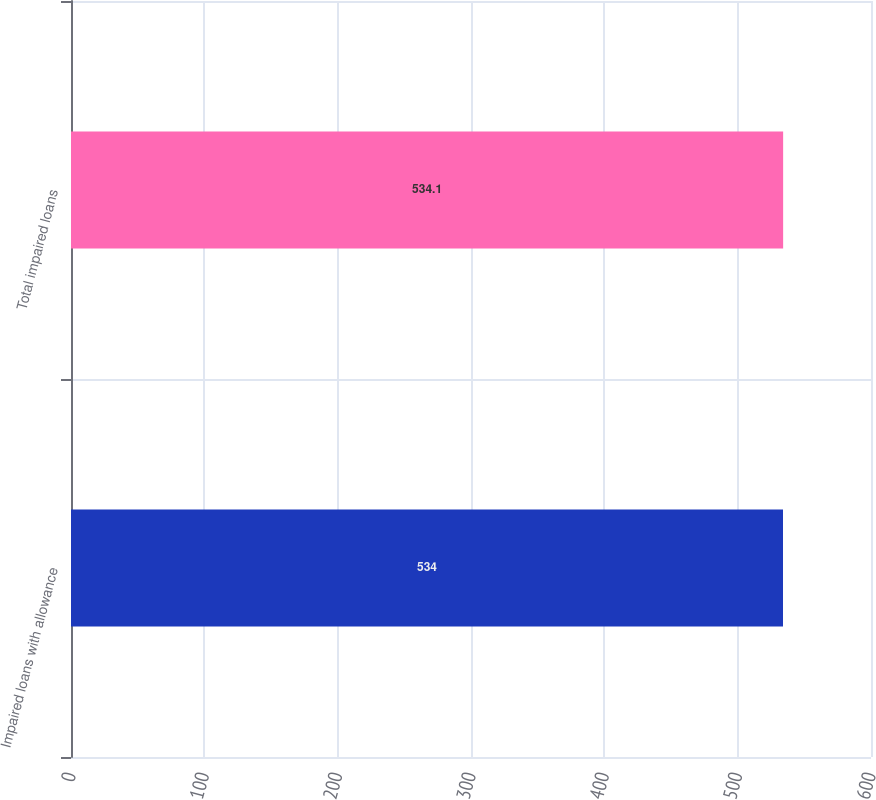Convert chart. <chart><loc_0><loc_0><loc_500><loc_500><bar_chart><fcel>Impaired loans with allowance<fcel>Total impaired loans<nl><fcel>534<fcel>534.1<nl></chart> 